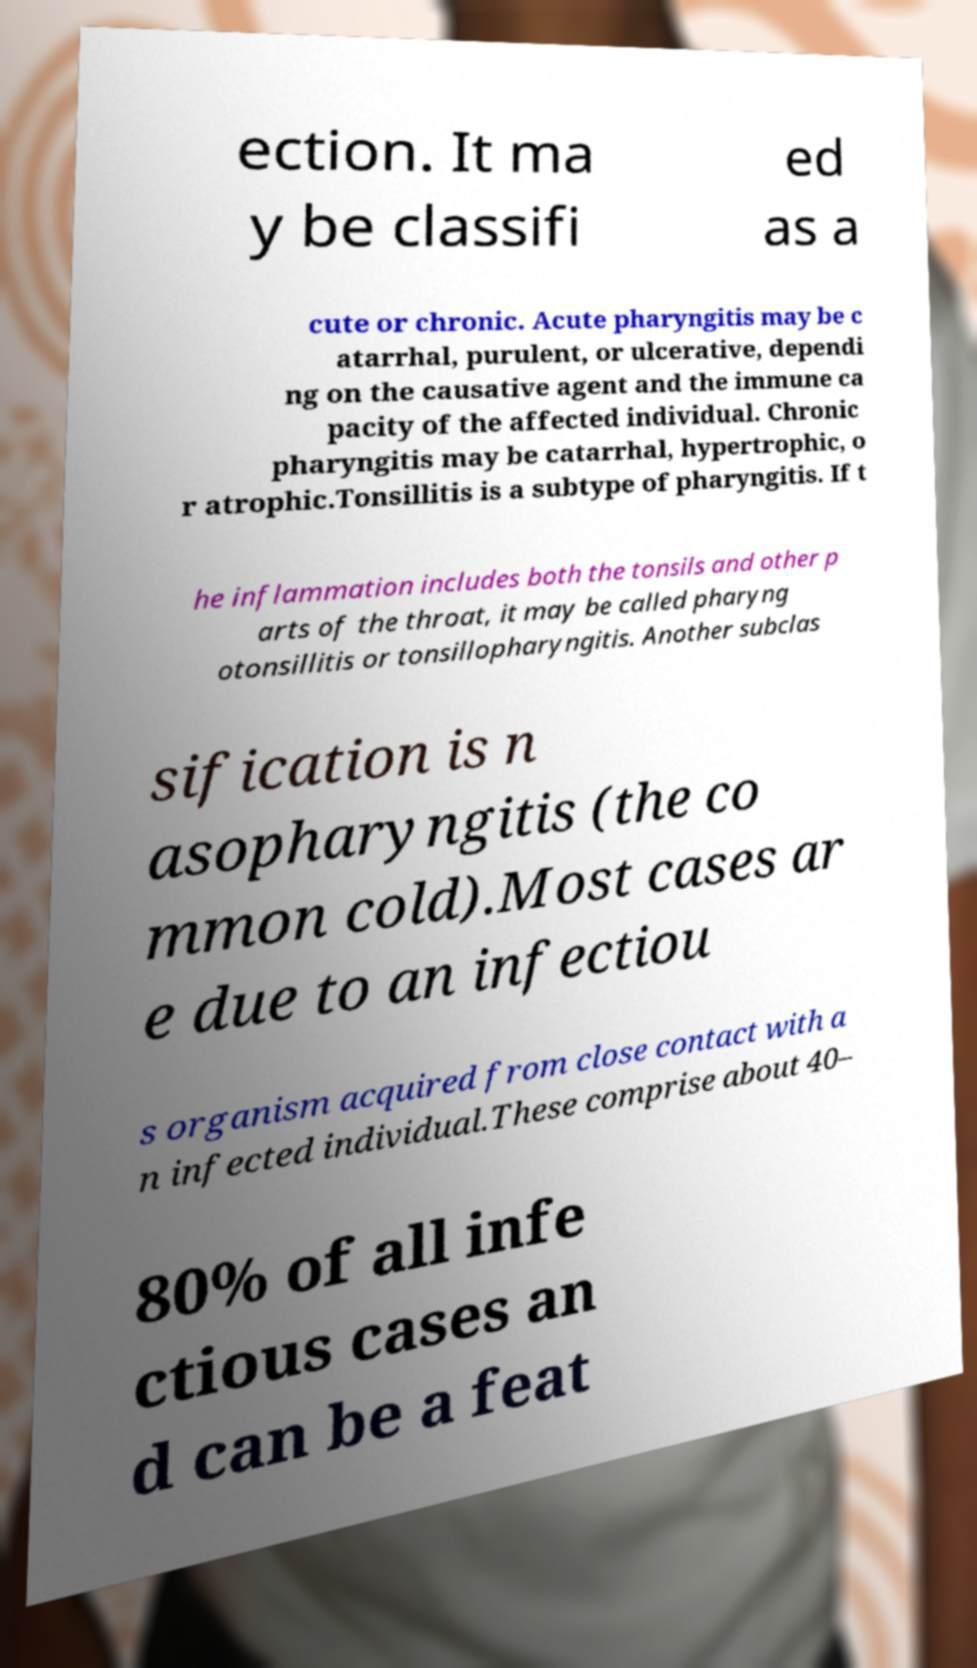Can you accurately transcribe the text from the provided image for me? ection. It ma y be classifi ed as a cute or chronic. Acute pharyngitis may be c atarrhal, purulent, or ulcerative, dependi ng on the causative agent and the immune ca pacity of the affected individual. Chronic pharyngitis may be catarrhal, hypertrophic, o r atrophic.Tonsillitis is a subtype of pharyngitis. If t he inflammation includes both the tonsils and other p arts of the throat, it may be called pharyng otonsillitis or tonsillopharyngitis. Another subclas sification is n asopharyngitis (the co mmon cold).Most cases ar e due to an infectiou s organism acquired from close contact with a n infected individual.These comprise about 40– 80% of all infe ctious cases an d can be a feat 